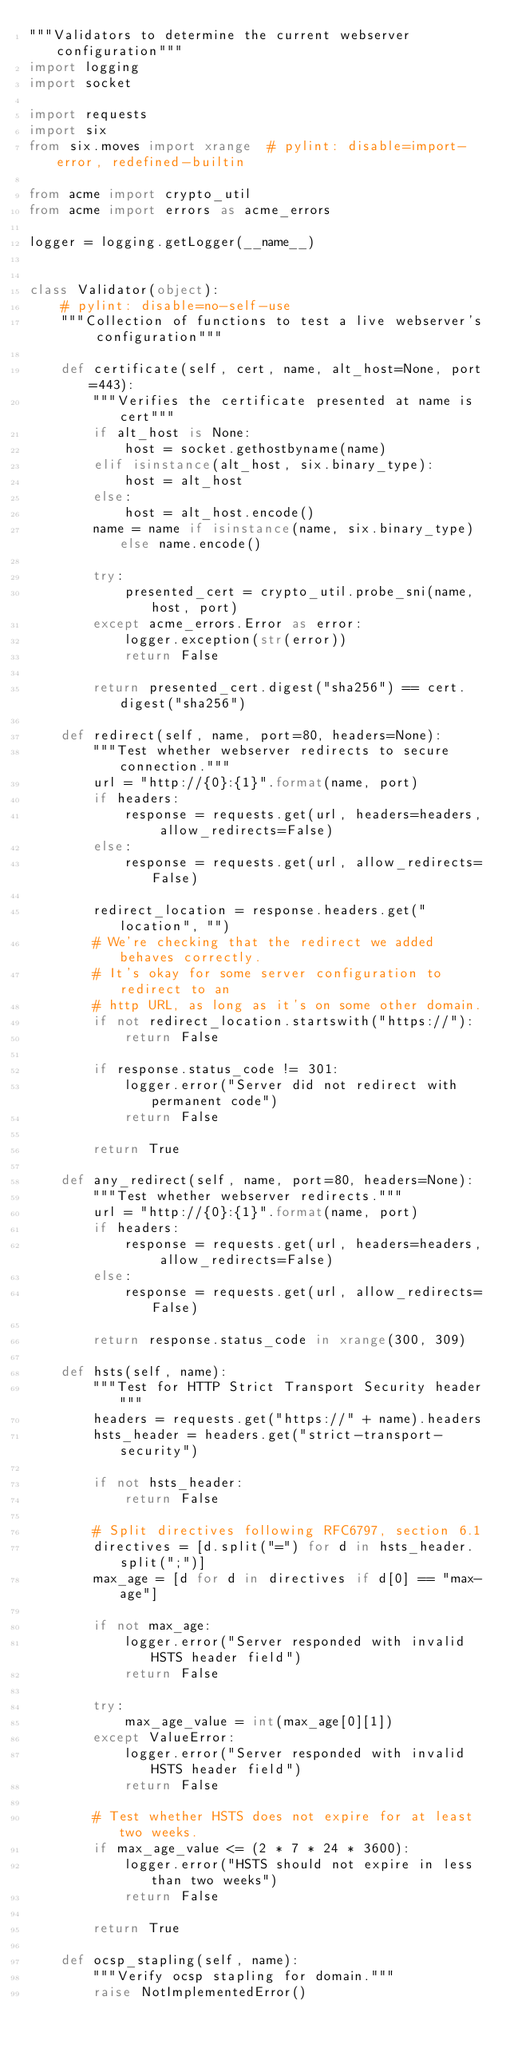<code> <loc_0><loc_0><loc_500><loc_500><_Python_>"""Validators to determine the current webserver configuration"""
import logging
import socket

import requests
import six
from six.moves import xrange  # pylint: disable=import-error, redefined-builtin

from acme import crypto_util
from acme import errors as acme_errors

logger = logging.getLogger(__name__)


class Validator(object):
    # pylint: disable=no-self-use
    """Collection of functions to test a live webserver's configuration"""

    def certificate(self, cert, name, alt_host=None, port=443):
        """Verifies the certificate presented at name is cert"""
        if alt_host is None:
            host = socket.gethostbyname(name)
        elif isinstance(alt_host, six.binary_type):
            host = alt_host
        else:
            host = alt_host.encode()
        name = name if isinstance(name, six.binary_type) else name.encode()

        try:
            presented_cert = crypto_util.probe_sni(name, host, port)
        except acme_errors.Error as error:
            logger.exception(str(error))
            return False

        return presented_cert.digest("sha256") == cert.digest("sha256")

    def redirect(self, name, port=80, headers=None):
        """Test whether webserver redirects to secure connection."""
        url = "http://{0}:{1}".format(name, port)
        if headers:
            response = requests.get(url, headers=headers, allow_redirects=False)
        else:
            response = requests.get(url, allow_redirects=False)

        redirect_location = response.headers.get("location", "")
        # We're checking that the redirect we added behaves correctly.
        # It's okay for some server configuration to redirect to an
        # http URL, as long as it's on some other domain.
        if not redirect_location.startswith("https://"):
            return False

        if response.status_code != 301:
            logger.error("Server did not redirect with permanent code")
            return False

        return True

    def any_redirect(self, name, port=80, headers=None):
        """Test whether webserver redirects."""
        url = "http://{0}:{1}".format(name, port)
        if headers:
            response = requests.get(url, headers=headers, allow_redirects=False)
        else:
            response = requests.get(url, allow_redirects=False)

        return response.status_code in xrange(300, 309)

    def hsts(self, name):
        """Test for HTTP Strict Transport Security header"""
        headers = requests.get("https://" + name).headers
        hsts_header = headers.get("strict-transport-security")

        if not hsts_header:
            return False

        # Split directives following RFC6797, section 6.1
        directives = [d.split("=") for d in hsts_header.split(";")]
        max_age = [d for d in directives if d[0] == "max-age"]

        if not max_age:
            logger.error("Server responded with invalid HSTS header field")
            return False

        try:
            max_age_value = int(max_age[0][1])
        except ValueError:
            logger.error("Server responded with invalid HSTS header field")
            return False

        # Test whether HSTS does not expire for at least two weeks.
        if max_age_value <= (2 * 7 * 24 * 3600):
            logger.error("HSTS should not expire in less than two weeks")
            return False

        return True

    def ocsp_stapling(self, name):
        """Verify ocsp stapling for domain."""
        raise NotImplementedError()
</code> 